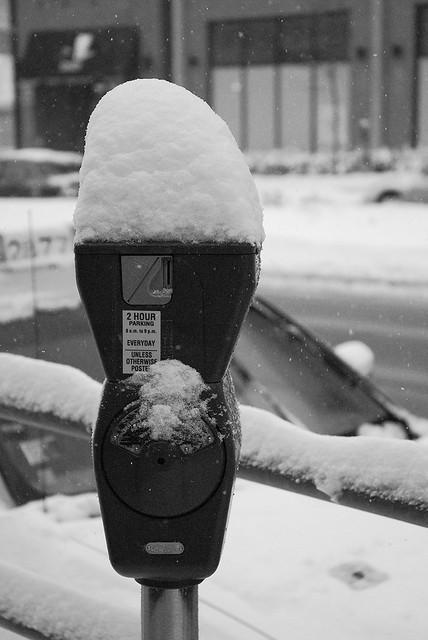How many cars are there?
Give a very brief answer. 2. How many people in the picture?
Give a very brief answer. 0. 